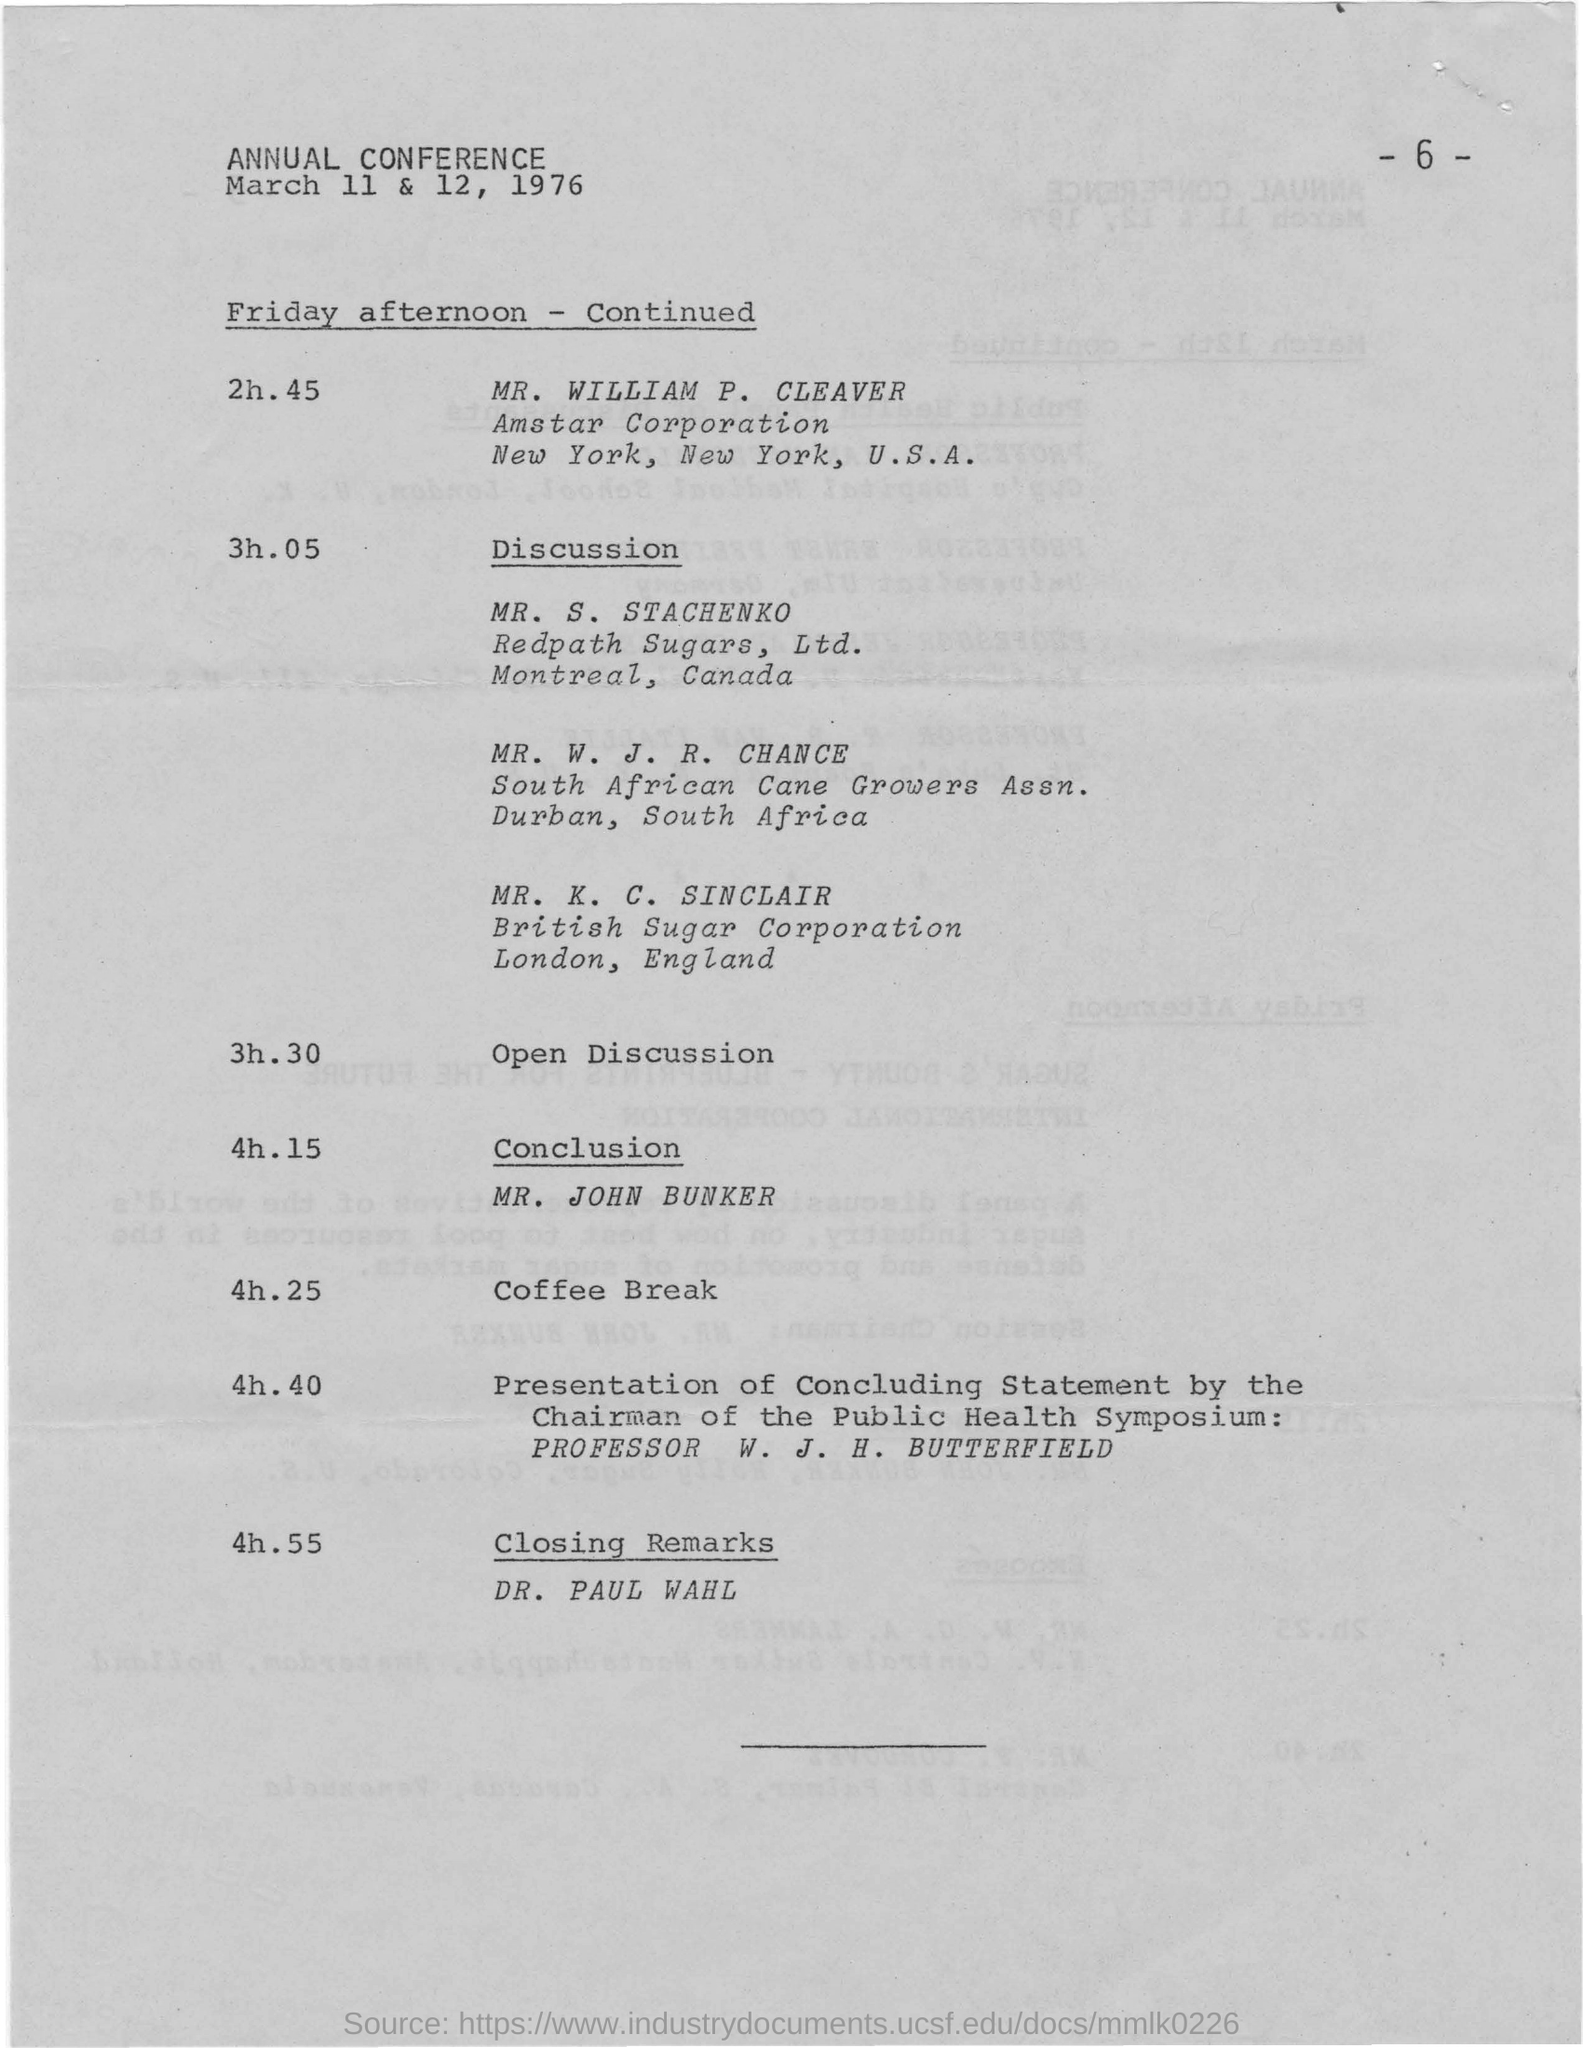When is the annual conference scheduled?
Provide a short and direct response. March 11 & 12, 1976. Who concluded the annual conference with closing remarks?
Provide a succinct answer. DR. PAUL WAHL. 